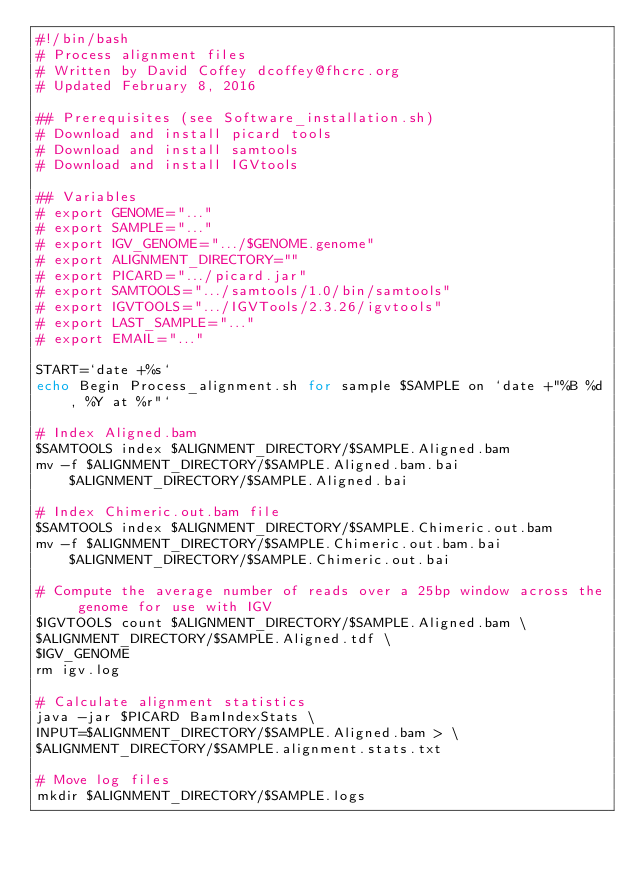<code> <loc_0><loc_0><loc_500><loc_500><_Bash_>#!/bin/bash
# Process alignment files
# Written by David Coffey dcoffey@fhcrc.org
# Updated February 8, 2016

## Prerequisites (see Software_installation.sh)
# Download and install picard tools
# Download and install samtools
# Download and install IGVtools

## Variables
# export GENOME="..."
# export SAMPLE="..."
# export IGV_GENOME=".../$GENOME.genome"
# export ALIGNMENT_DIRECTORY=""
# export PICARD=".../picard.jar"
# export SAMTOOLS=".../samtools/1.0/bin/samtools"
# export IGVTOOLS=".../IGVTools/2.3.26/igvtools"
# export LAST_SAMPLE="..."
# export EMAIL="..."

START=`date +%s`
echo Begin Process_alignment.sh for sample $SAMPLE on `date +"%B %d, %Y at %r"`

# Index Aligned.bam 
$SAMTOOLS index $ALIGNMENT_DIRECTORY/$SAMPLE.Aligned.bam
mv -f $ALIGNMENT_DIRECTORY/$SAMPLE.Aligned.bam.bai $ALIGNMENT_DIRECTORY/$SAMPLE.Aligned.bai

# Index Chimeric.out.bam file
$SAMTOOLS index $ALIGNMENT_DIRECTORY/$SAMPLE.Chimeric.out.bam
mv -f $ALIGNMENT_DIRECTORY/$SAMPLE.Chimeric.out.bam.bai $ALIGNMENT_DIRECTORY/$SAMPLE.Chimeric.out.bai

# Compute the average number of reads over a 25bp window across the genome for use with IGV
$IGVTOOLS count $ALIGNMENT_DIRECTORY/$SAMPLE.Aligned.bam \
$ALIGNMENT_DIRECTORY/$SAMPLE.Aligned.tdf \
$IGV_GENOME
rm igv.log

# Calculate alignment statistics
java -jar $PICARD BamIndexStats \
INPUT=$ALIGNMENT_DIRECTORY/$SAMPLE.Aligned.bam > \
$ALIGNMENT_DIRECTORY/$SAMPLE.alignment.stats.txt

# Move log files
mkdir $ALIGNMENT_DIRECTORY/$SAMPLE.logs</code> 